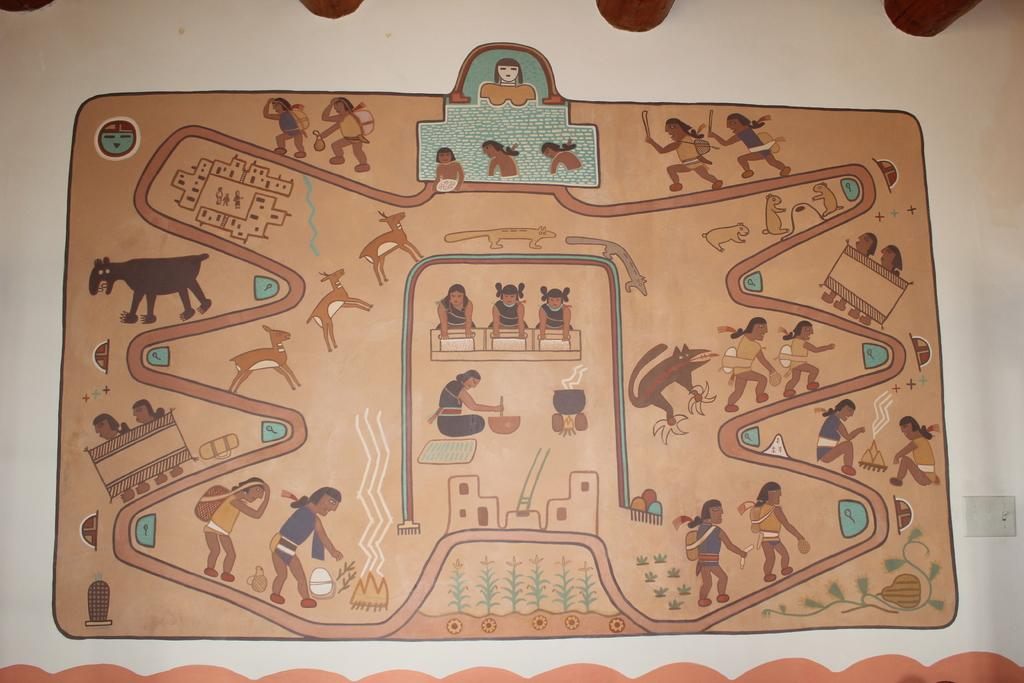What can be observed on the surface of the object in the image? There are many different pictures printed on the surface in the image. What is the color of the background in the image? The background of the image is in brown color. What type of hat is being worn by the person in the image? There is no person or hat present in the image; it features an object with pictures printed on its surface against a brown background. 